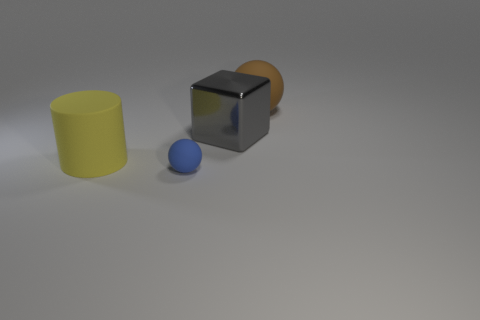Add 4 tiny cyan balls. How many objects exist? 8 Subtract all brown balls. How many balls are left? 1 Subtract all cyan cylinders. How many blue spheres are left? 1 Subtract all cubes. How many objects are left? 3 Subtract 1 balls. How many balls are left? 1 Subtract all big purple matte cylinders. Subtract all big gray metallic cubes. How many objects are left? 3 Add 2 large things. How many large things are left? 5 Add 4 large green metallic balls. How many large green metallic balls exist? 4 Subtract 1 gray blocks. How many objects are left? 3 Subtract all yellow spheres. Subtract all blue cylinders. How many spheres are left? 2 